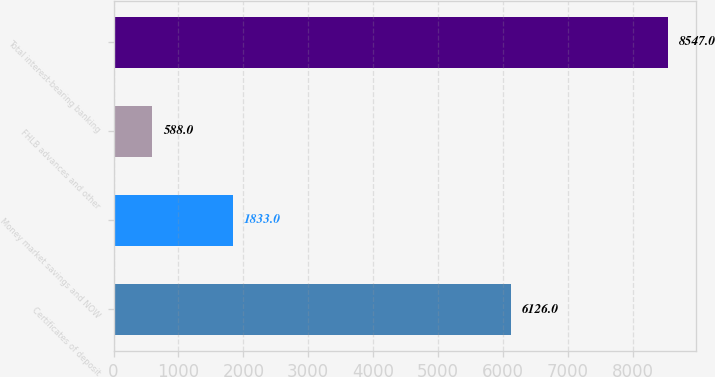Convert chart. <chart><loc_0><loc_0><loc_500><loc_500><bar_chart><fcel>Certificates of deposit<fcel>Money market savings and NOW<fcel>FHLB advances and other<fcel>Total interest-bearing banking<nl><fcel>6126<fcel>1833<fcel>588<fcel>8547<nl></chart> 